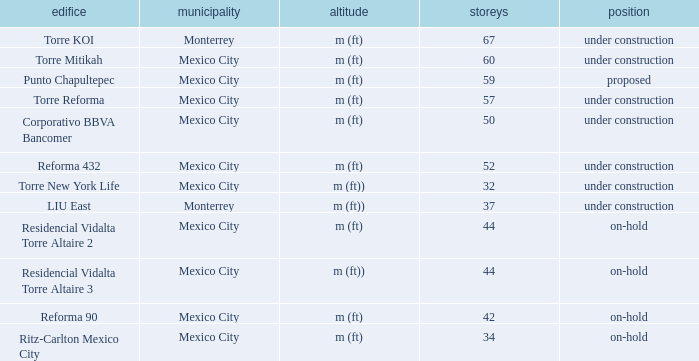How many stories is the torre reforma building? 1.0. 